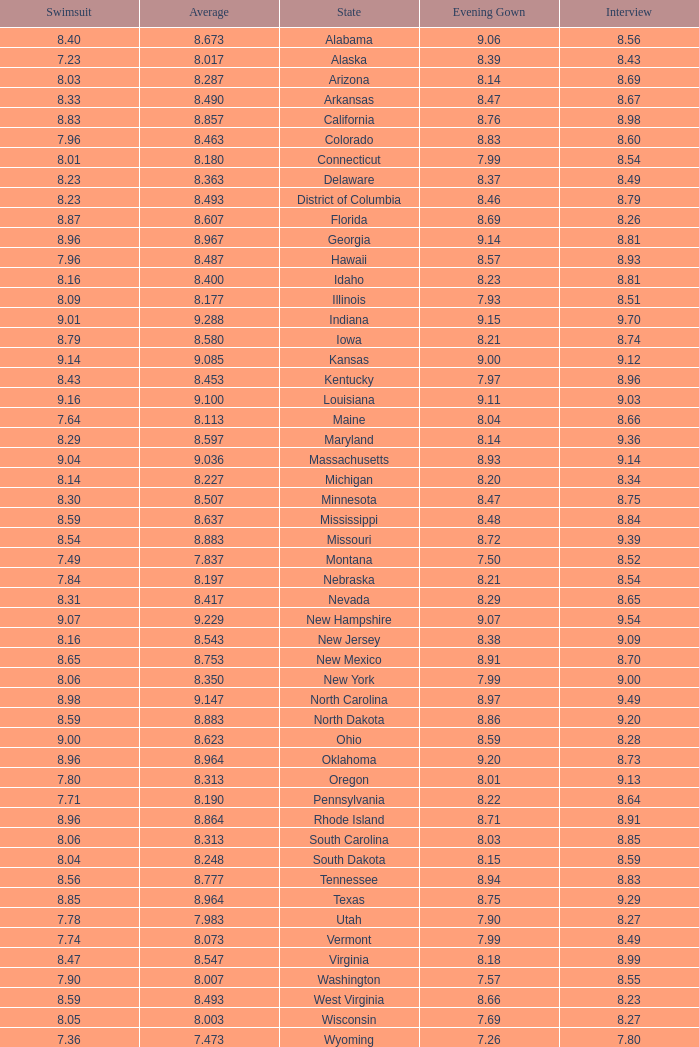Tell me the sum of interview for evening gown more than 8.37 and average of 8.363 None. 